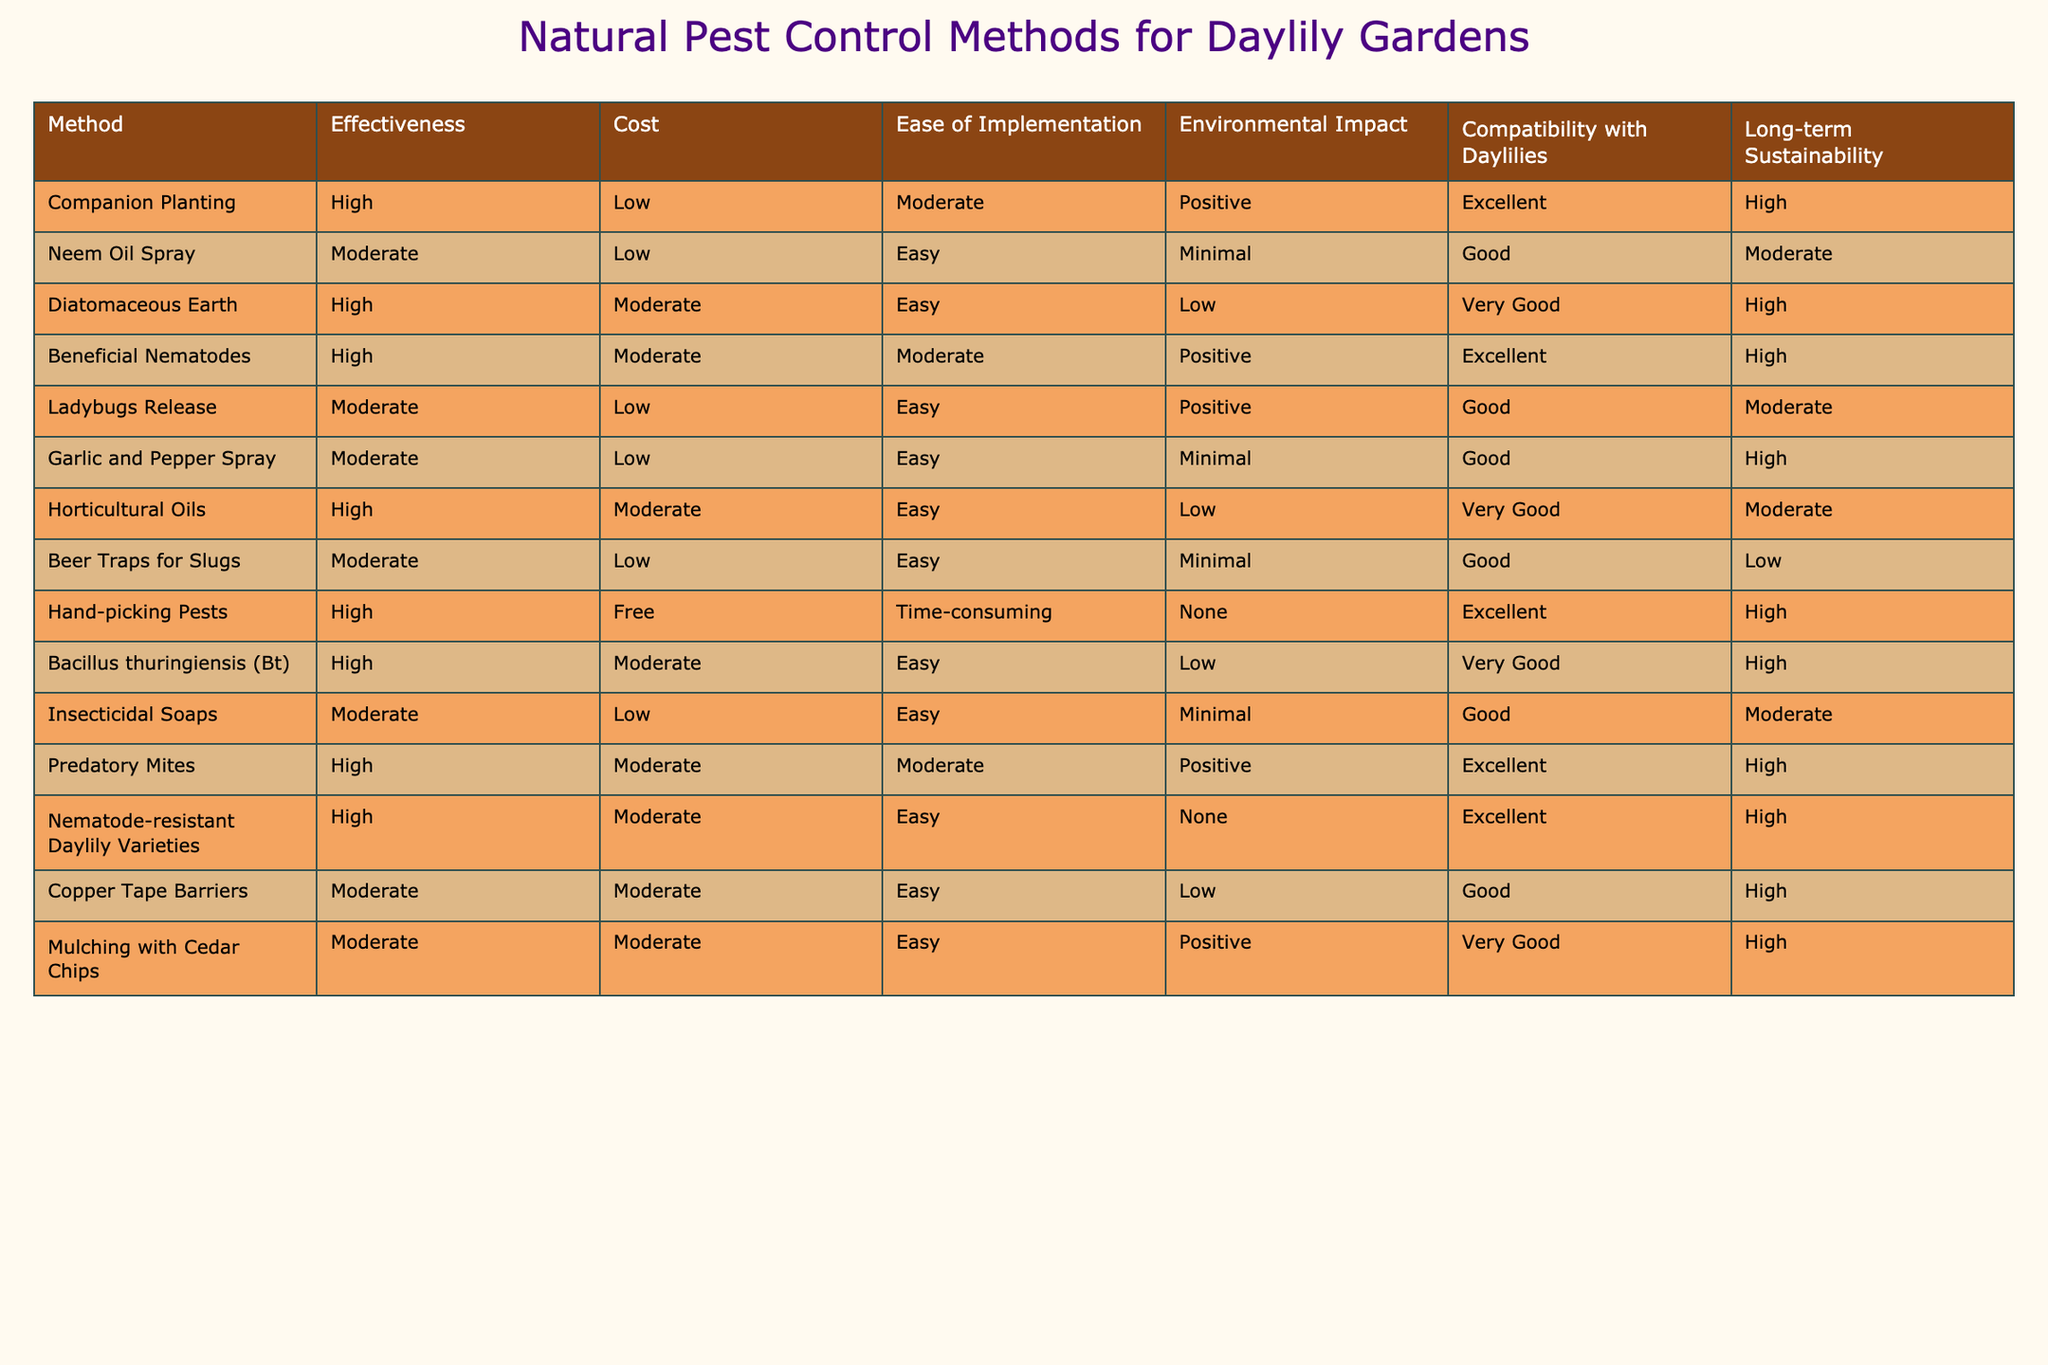What is the effectiveness rating of hand-picking pests? The effectiveness rating for hand-picking pests is found directly in the table under the "Effectiveness" column corresponding to the "Hand-picking Pests" row. It is categorized as "High."
Answer: High How many pest control methods have a low cost? To find this answer, I examine the "Cost" column and count how many methods are listed as "Low." There are 5 methods: Neem Oil Spray, Ladybugs Release, Garlic and Pepper Spray, Insecticidal Soaps, and Beer Traps for Slugs.
Answer: 5 Which pest control methods have a positive environmental impact? I check the "Environmental Impact" column and see which methods are marked as "Positive." These methods are Companion Planting, Beneficial Nematodes, Ladybugs Release, Horticultural Oils, Nematode-resistant Daylily Varieties, and Mulching with Cedar Chips. In total, there are 6 methods with a positive impact.
Answer: 6 Is diatomaceous earth considered easy to implement? The "Ease of Implementation" column indicates that diatomaceous earth is categorized as "Easy." This provides a clear answer to the question based on the contents of the table.
Answer: Yes Which pest control methods are rated as very good for compatibility with daylilies? I review the "Compatibility with Daylilies" column and filter for methods marked as "Very Good." These methods are Diatomaceous Earth, Horticultural Oils, Nematode-resistant Daylily Varieties, and Mulching with Cedar Chips. This gives me a total of 4 methods rated as very good.
Answer: 4 What are the methods with high effectiveness and low cost? I must look at both the "Effectiveness" column and the "Cost" column for methods categorized as "High" and "Low," respectively. The methods that meet both criteria are Neem Oil Spray and Ladybugs Release. Hence, we have 2 such methods in total.
Answer: 2 What is the long-term sustainability rating of the method with moderate ease of implementation and good compatibility with daylilies? First, I need to find methods that are categorized as "Moderate" in the "Ease of Implementation" column and "Good" in the "Compatibility with Daylilies" column. The methods that fit this description are Copper Tape Barriers and Insecticidal Soaps, both of which have a "High" long-term sustainability rating.
Answer: High Which pest control method is free and has an excellent compatibility with daylilies? By checking the "Ease of Implementation" column, I find that the only method that is free is "Hand-picking Pests," which I further confirm has an "Excellent" compatibility with daylilies from the corresponding column.
Answer: Yes 